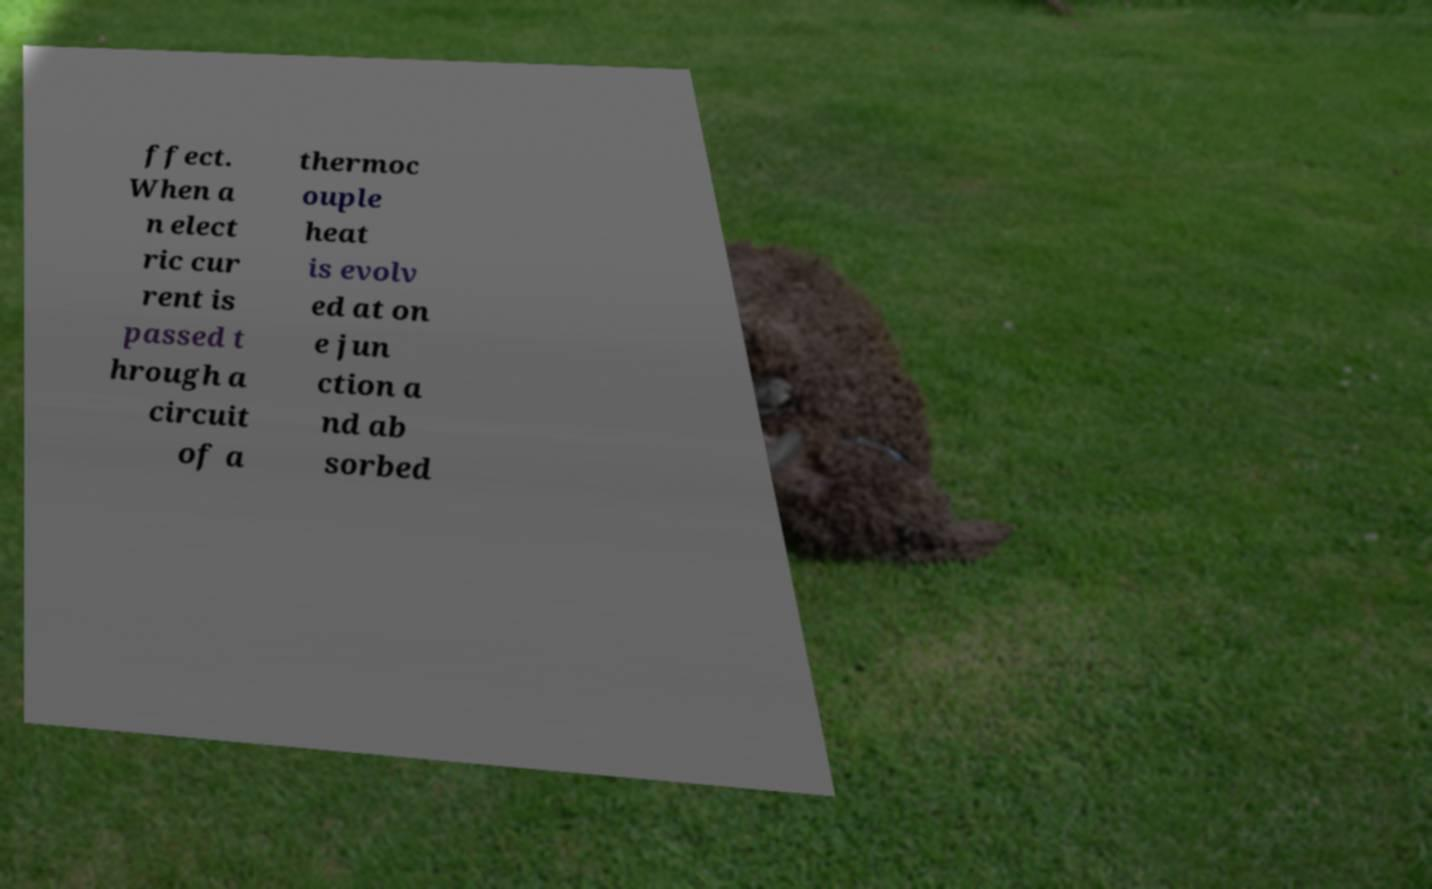There's text embedded in this image that I need extracted. Can you transcribe it verbatim? ffect. When a n elect ric cur rent is passed t hrough a circuit of a thermoc ouple heat is evolv ed at on e jun ction a nd ab sorbed 